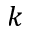<formula> <loc_0><loc_0><loc_500><loc_500>k</formula> 